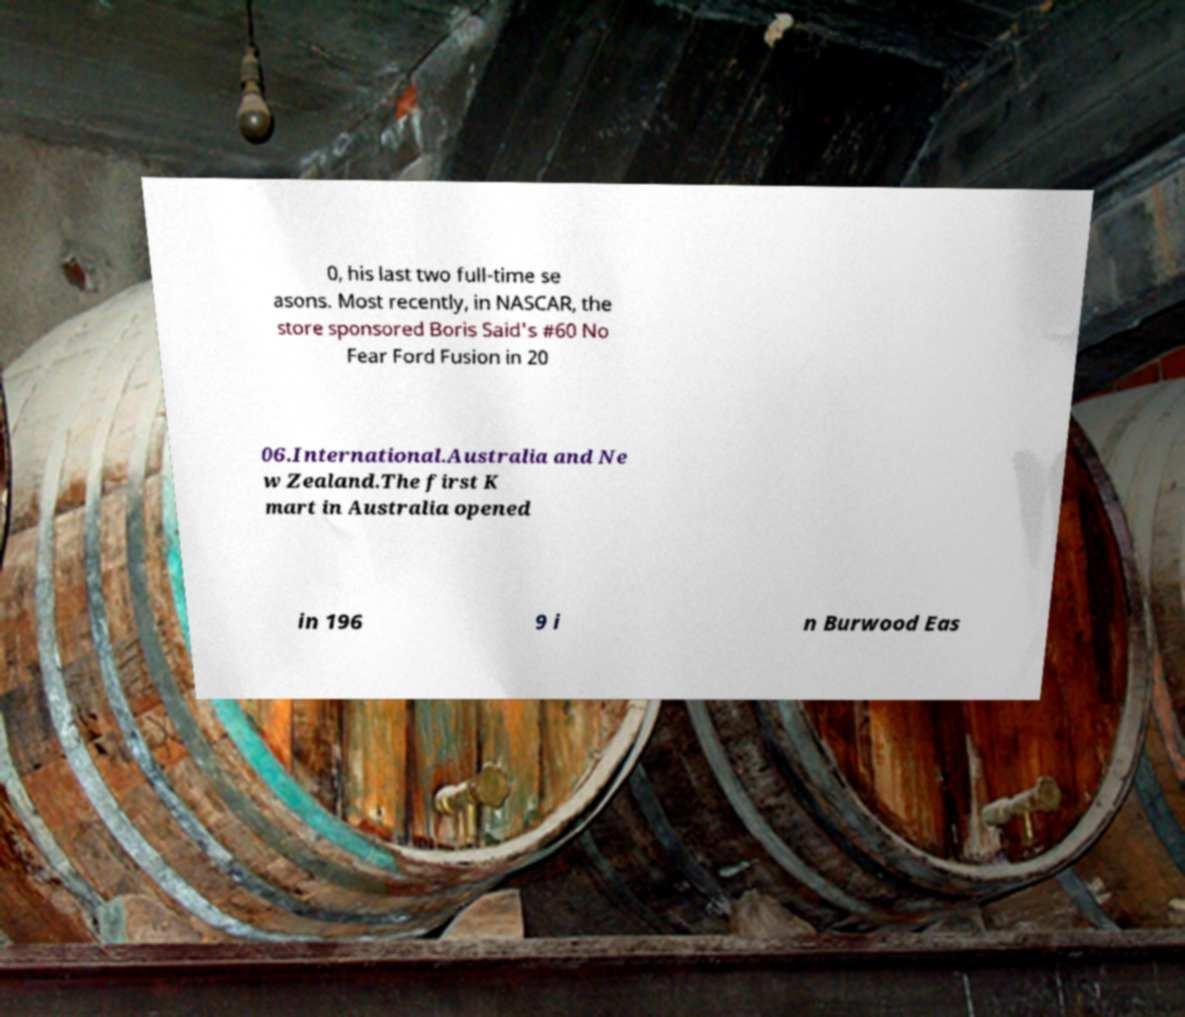Can you read and provide the text displayed in the image?This photo seems to have some interesting text. Can you extract and type it out for me? 0, his last two full-time se asons. Most recently, in NASCAR, the store sponsored Boris Said's #60 No Fear Ford Fusion in 20 06.International.Australia and Ne w Zealand.The first K mart in Australia opened in 196 9 i n Burwood Eas 